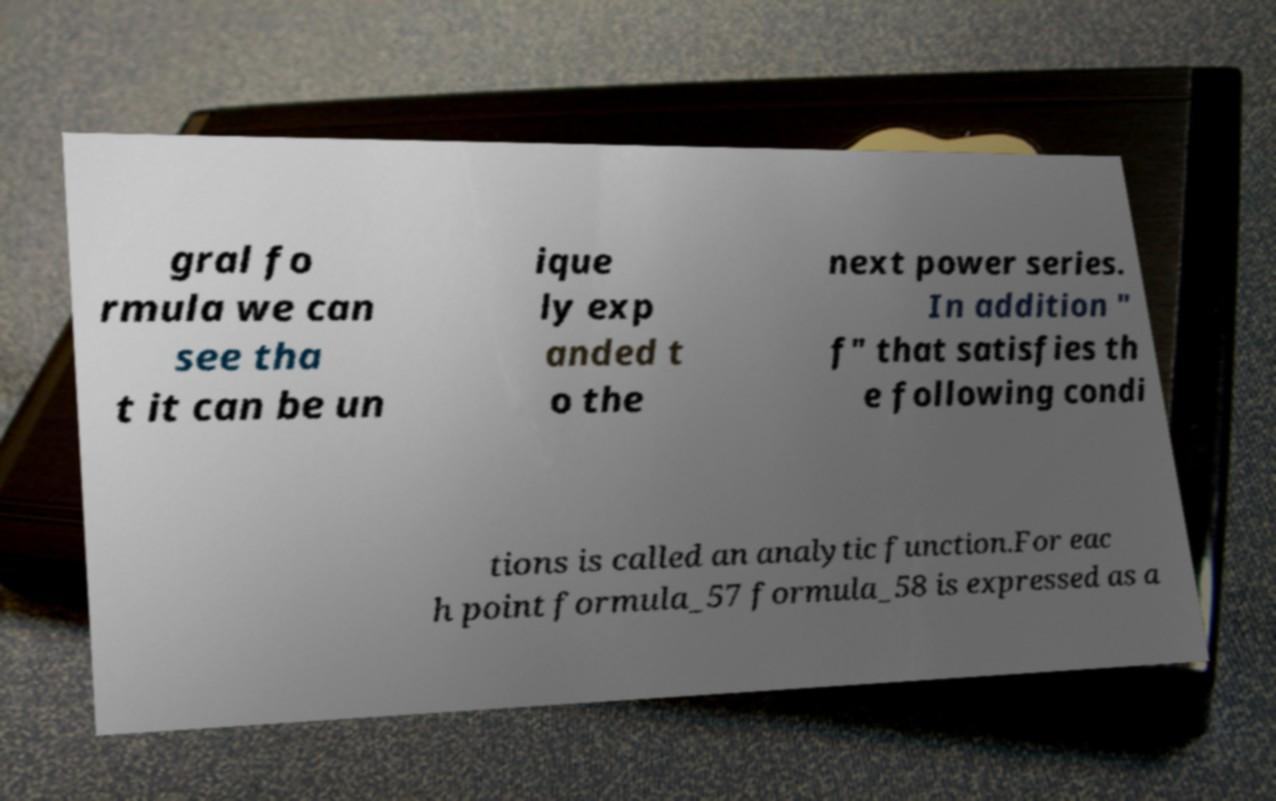Can you read and provide the text displayed in the image?This photo seems to have some interesting text. Can you extract and type it out for me? gral fo rmula we can see tha t it can be un ique ly exp anded t o the next power series. In addition " f" that satisfies th e following condi tions is called an analytic function.For eac h point formula_57 formula_58 is expressed as a 